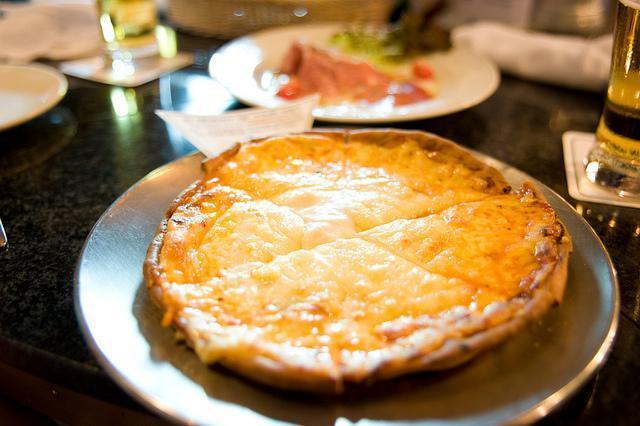Evaluate: Does the caption "The pizza is at the edge of the dining table." match the image?
Answer yes or no. No. 